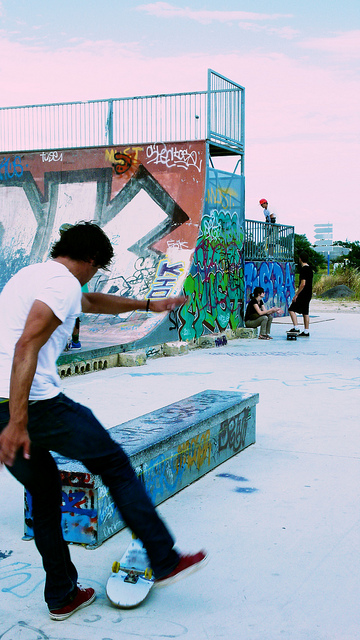How many people are using the skatepark in this image? The image captures a total of three individuals at the skatepark. Two are positioned atop the ramp, each focused on their skateboards, likely preparing to drop in or just enjoying the atmosphere, while the third person is actively skateboarding, performing a trick on the ramp. 